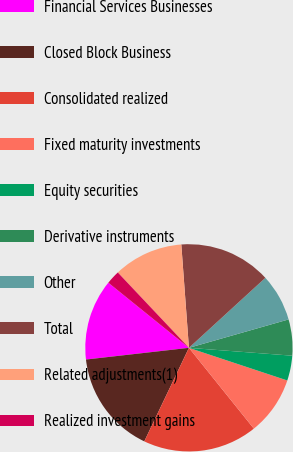Convert chart to OTSL. <chart><loc_0><loc_0><loc_500><loc_500><pie_chart><fcel>Financial Services Businesses<fcel>Closed Block Business<fcel>Consolidated realized<fcel>Fixed maturity investments<fcel>Equity securities<fcel>Derivative instruments<fcel>Other<fcel>Total<fcel>Related adjustments(1)<fcel>Realized investment gains<nl><fcel>12.62%<fcel>16.11%<fcel>17.86%<fcel>9.13%<fcel>3.89%<fcel>5.63%<fcel>7.38%<fcel>14.37%<fcel>10.87%<fcel>2.14%<nl></chart> 